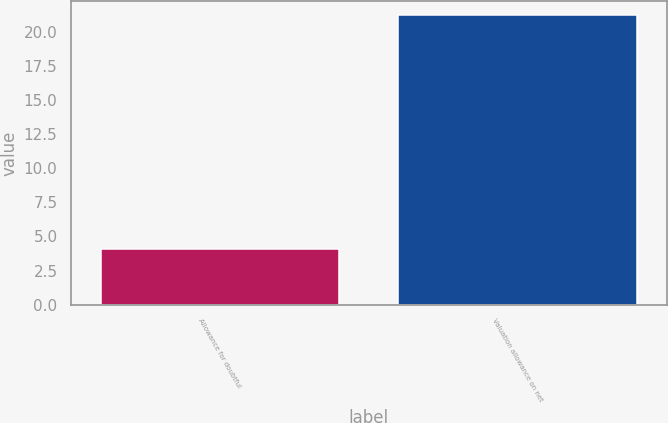Convert chart to OTSL. <chart><loc_0><loc_0><loc_500><loc_500><bar_chart><fcel>Allowance for doubtful<fcel>Valuation allowance on net<nl><fcel>4.1<fcel>21.2<nl></chart> 